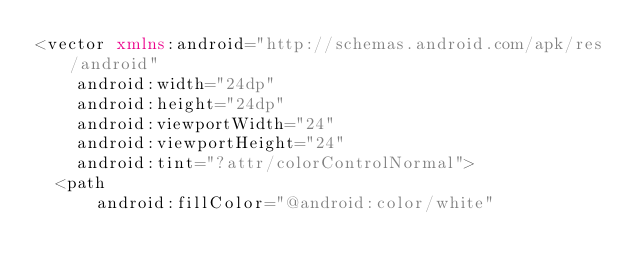Convert code to text. <code><loc_0><loc_0><loc_500><loc_500><_XML_><vector xmlns:android="http://schemas.android.com/apk/res/android"
    android:width="24dp"
    android:height="24dp"
    android:viewportWidth="24"
    android:viewportHeight="24"
    android:tint="?attr/colorControlNormal">
  <path
      android:fillColor="@android:color/white"</code> 